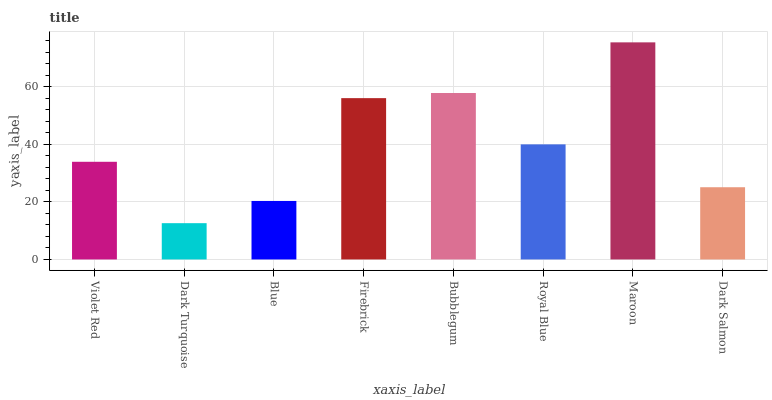Is Dark Turquoise the minimum?
Answer yes or no. Yes. Is Maroon the maximum?
Answer yes or no. Yes. Is Blue the minimum?
Answer yes or no. No. Is Blue the maximum?
Answer yes or no. No. Is Blue greater than Dark Turquoise?
Answer yes or no. Yes. Is Dark Turquoise less than Blue?
Answer yes or no. Yes. Is Dark Turquoise greater than Blue?
Answer yes or no. No. Is Blue less than Dark Turquoise?
Answer yes or no. No. Is Royal Blue the high median?
Answer yes or no. Yes. Is Violet Red the low median?
Answer yes or no. Yes. Is Dark Turquoise the high median?
Answer yes or no. No. Is Bubblegum the low median?
Answer yes or no. No. 